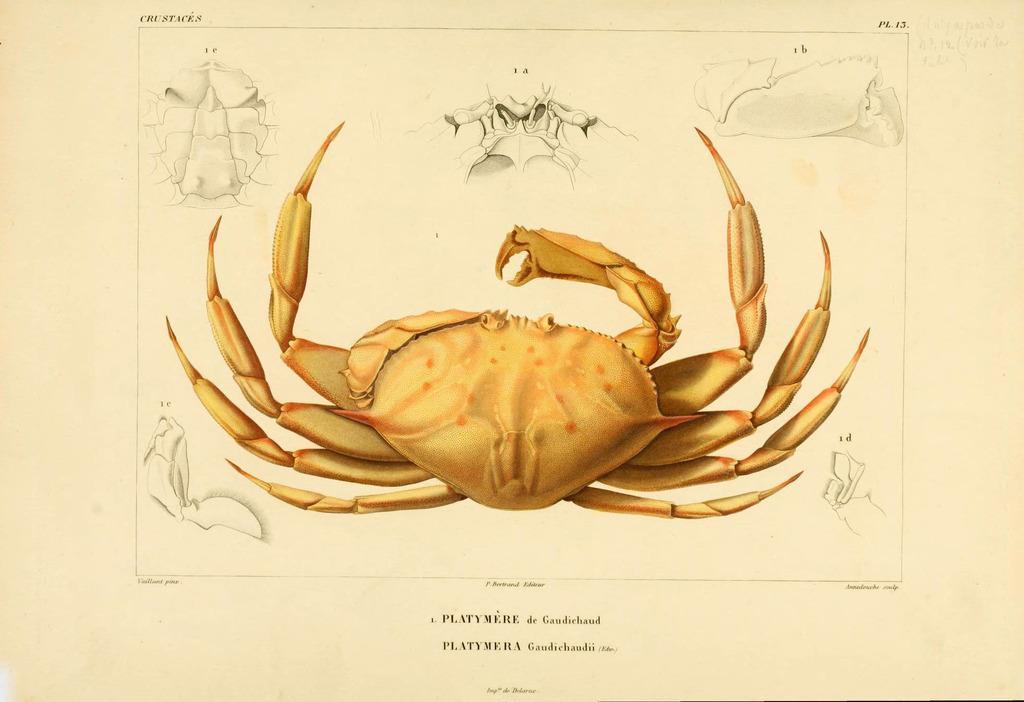Please provide a concise description of this image. In this picture I can see a paper, there are words, numbers and there are images on the paper. 